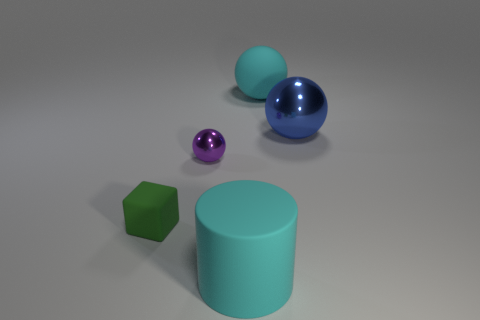The object that is to the left of the matte cylinder and behind the small green matte cube is made of what material?
Your response must be concise. Metal. Is the number of big rubber things that are on the left side of the tiny block less than the number of small matte things that are in front of the cyan rubber ball?
Make the answer very short. Yes. How many other objects are the same size as the cyan cylinder?
Provide a short and direct response. 2. There is a cyan thing behind the big blue metal ball that is on the right side of the matte object that is left of the large cylinder; what is its shape?
Your answer should be compact. Sphere. How many blue things are either large shiny objects or large things?
Offer a terse response. 1. There is a cyan thing behind the tiny rubber cube; how many spheres are on the left side of it?
Offer a terse response. 1. Are there any other things that are the same color as the small shiny thing?
Offer a terse response. No. What shape is the big object that is the same material as the tiny purple object?
Your answer should be very brief. Sphere. Does the big metal object have the same color as the large cylinder?
Provide a succinct answer. No. Is the big cyan thing that is behind the tiny green cube made of the same material as the sphere that is left of the large cyan cylinder?
Offer a terse response. No. 